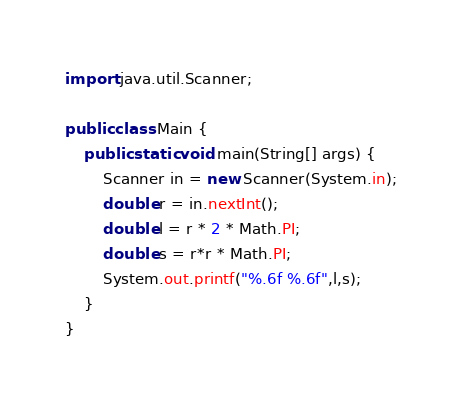Convert code to text. <code><loc_0><loc_0><loc_500><loc_500><_Java_>import java.util.Scanner;

public class Main {
    public static void main(String[] args) {
    	Scanner in = new Scanner(System.in);
    	double r = in.nextInt();
    	double l = r * 2 * Math.PI;
    	double s = r*r * Math.PI;
    	System.out.printf("%.6f %.6f",l,s);
	}
}</code> 